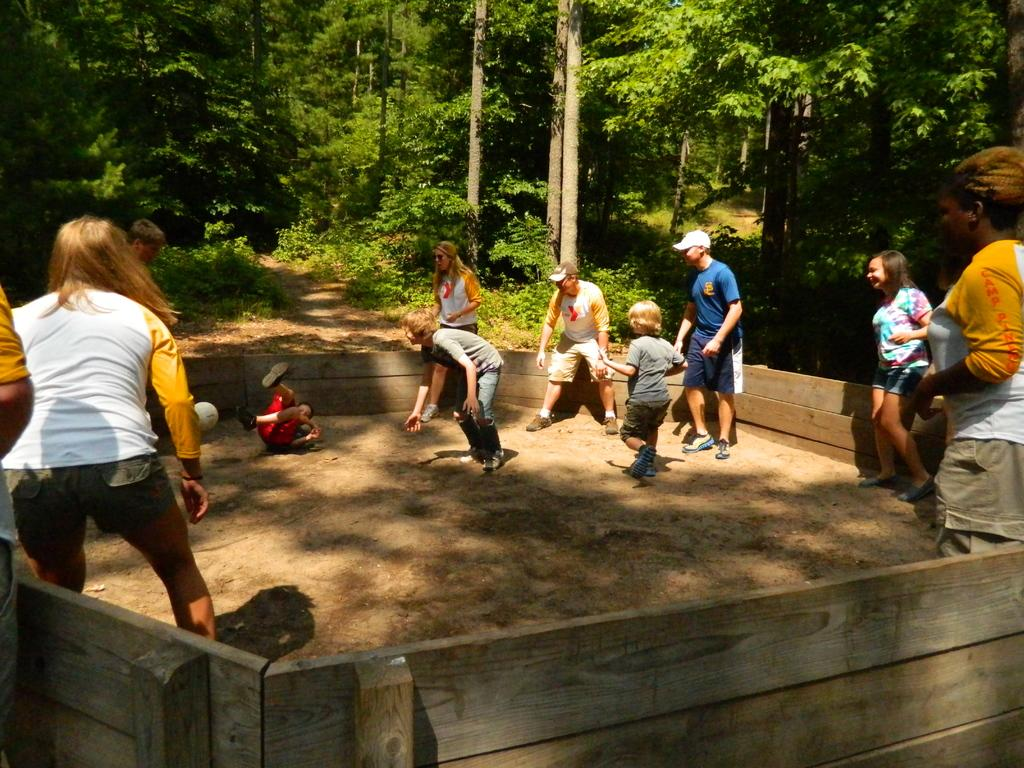What are the people in the image wearing? The people in the image are wearing different color dresses. What can be seen in the background of the image? There are trees and wooden fencing visible in the background of the image. What direction are the people in the image facing? The provided facts do not mention the direction the people are facing, so it cannot be determined from the image. 